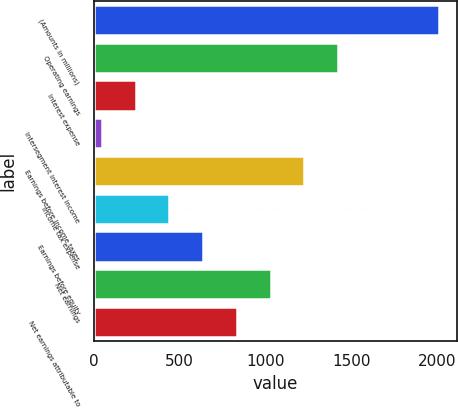<chart> <loc_0><loc_0><loc_500><loc_500><bar_chart><fcel>(Amounts in millions)<fcel>Operating earnings<fcel>Interest expense<fcel>Intersegment interest income<fcel>Earnings before income taxes<fcel>Income tax expense<fcel>Earnings before equity<fcel>Net earnings<fcel>Net earnings attributable to<nl><fcel>2013<fcel>1423.41<fcel>244.23<fcel>47.7<fcel>1226.88<fcel>440.76<fcel>637.29<fcel>1030.35<fcel>833.82<nl></chart> 